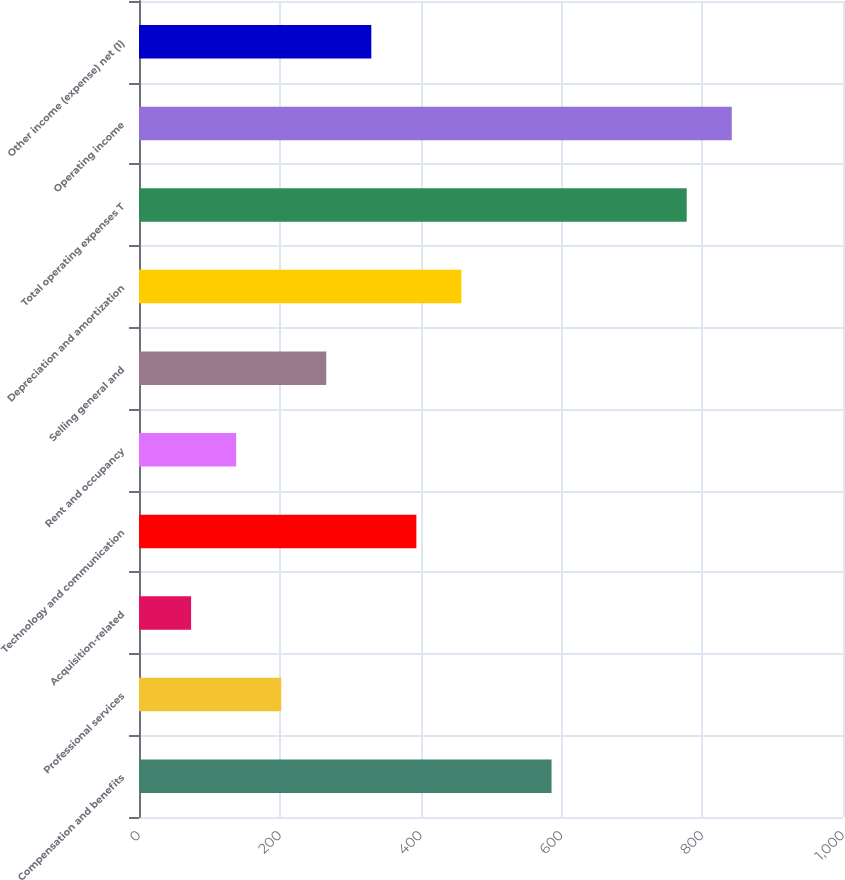Convert chart. <chart><loc_0><loc_0><loc_500><loc_500><bar_chart><fcel>Compensation and benefits<fcel>Professional services<fcel>Acquisition-related<fcel>Technology and communication<fcel>Rent and occupancy<fcel>Selling general and<fcel>Depreciation and amortization<fcel>Total operating expenses T<fcel>Operating income<fcel>Other income (expense) net (1)<nl><fcel>586<fcel>202<fcel>74<fcel>394<fcel>138<fcel>266<fcel>458<fcel>778<fcel>842<fcel>330<nl></chart> 